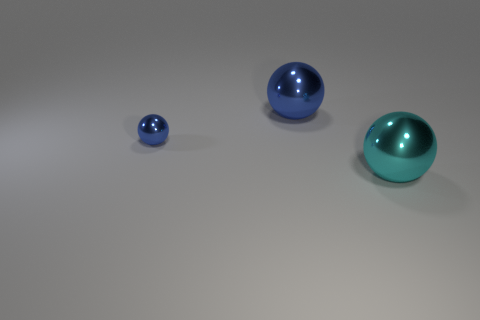There is a big metal thing that is behind the blue sphere in front of the thing behind the small shiny object; what color is it?
Offer a very short reply. Blue. Is the color of the ball behind the tiny blue shiny sphere the same as the big sphere in front of the small blue ball?
Your response must be concise. No. There is a blue metallic sphere behind the tiny blue metal object; how many big spheres are on the right side of it?
Make the answer very short. 1. Are there any yellow shiny objects?
Your answer should be compact. No. How many other things are there of the same color as the small object?
Offer a terse response. 1. Are there fewer metallic spheres than large cyan objects?
Make the answer very short. No. There is a large blue metal object; are there any small things behind it?
Offer a very short reply. No. There is a sphere that is the same size as the cyan thing; what is its color?
Keep it short and to the point. Blue. How many small blue things have the same material as the cyan thing?
Provide a short and direct response. 1. What number of other objects are the same size as the cyan metal object?
Your answer should be very brief. 1. 